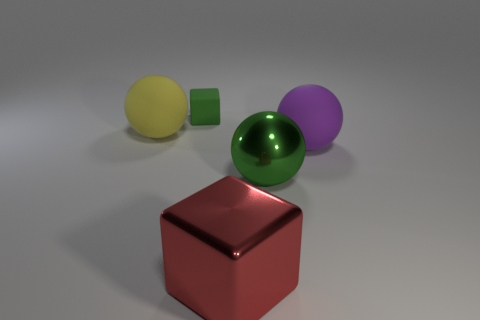Add 3 small blue metal balls. How many objects exist? 8 Subtract all spheres. How many objects are left? 2 Subtract 1 yellow balls. How many objects are left? 4 Subtract all big red metallic blocks. Subtract all small brown rubber blocks. How many objects are left? 4 Add 3 tiny objects. How many tiny objects are left? 4 Add 4 big brown rubber balls. How many big brown rubber balls exist? 4 